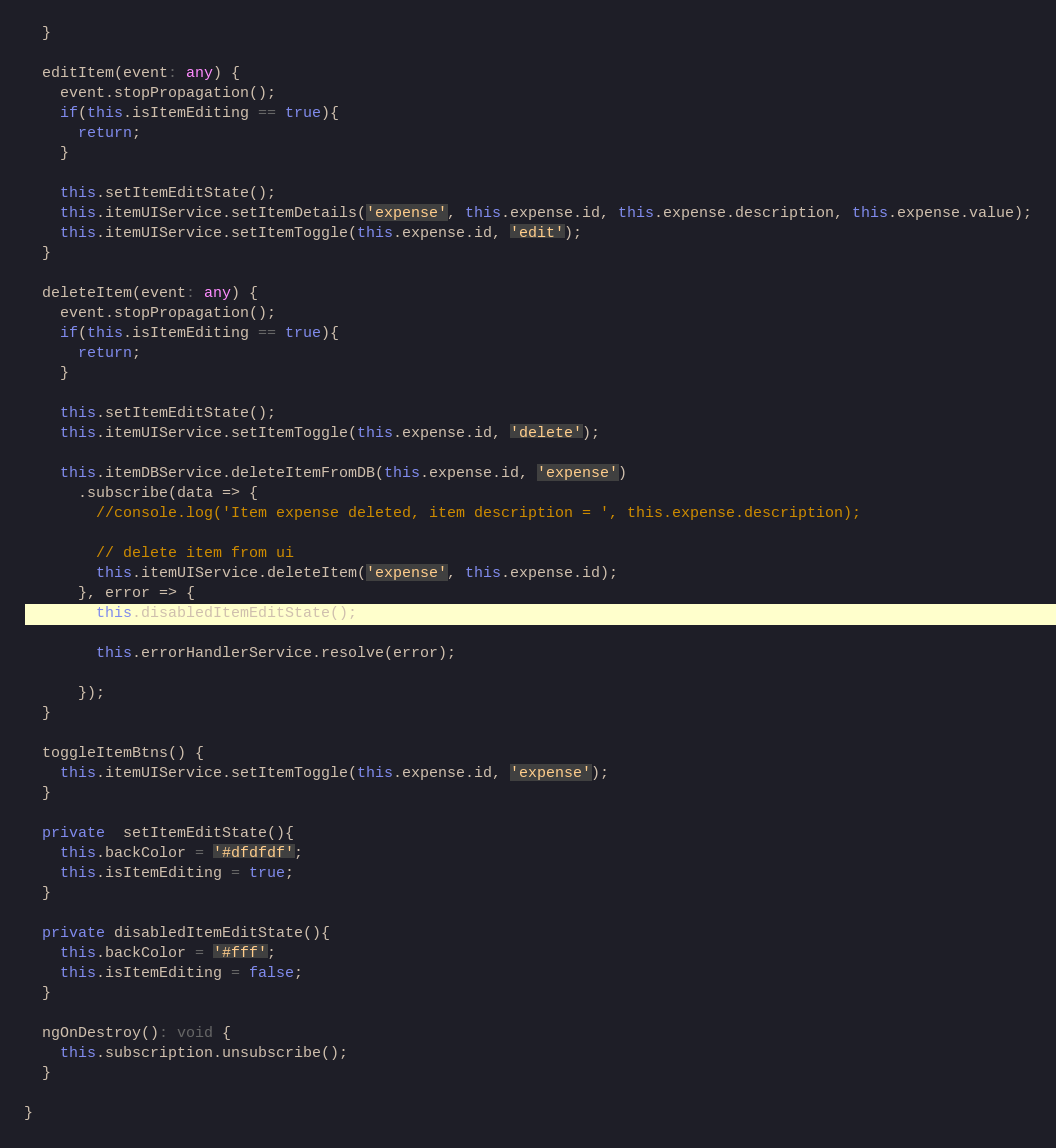<code> <loc_0><loc_0><loc_500><loc_500><_TypeScript_>  }

  editItem(event: any) {
    event.stopPropagation();
    if(this.isItemEditing == true){
      return;
    }

    this.setItemEditState();
    this.itemUIService.setItemDetails('expense', this.expense.id, this.expense.description, this.expense.value);
    this.itemUIService.setItemToggle(this.expense.id, 'edit');
  }

  deleteItem(event: any) {
    event.stopPropagation();
    if(this.isItemEditing == true){
      return;
    }

    this.setItemEditState();
    this.itemUIService.setItemToggle(this.expense.id, 'delete');

    this.itemDBService.deleteItemFromDB(this.expense.id, 'expense')
      .subscribe(data => {
        //console.log('Item expense deleted, item description = ', this.expense.description);

        // delete item from ui
        this.itemUIService.deleteItem('expense', this.expense.id);
      }, error => {
        this.disabledItemEditState();

        this.errorHandlerService.resolve(error);

      });
  }

  toggleItemBtns() {
    this.itemUIService.setItemToggle(this.expense.id, 'expense');
  }

  private  setItemEditState(){
    this.backColor = '#dfdfdf';
    this.isItemEditing = true;
  }

  private disabledItemEditState(){
    this.backColor = '#fff';
    this.isItemEditing = false;
  }

  ngOnDestroy(): void {
    this.subscription.unsubscribe();
  }

}
</code> 